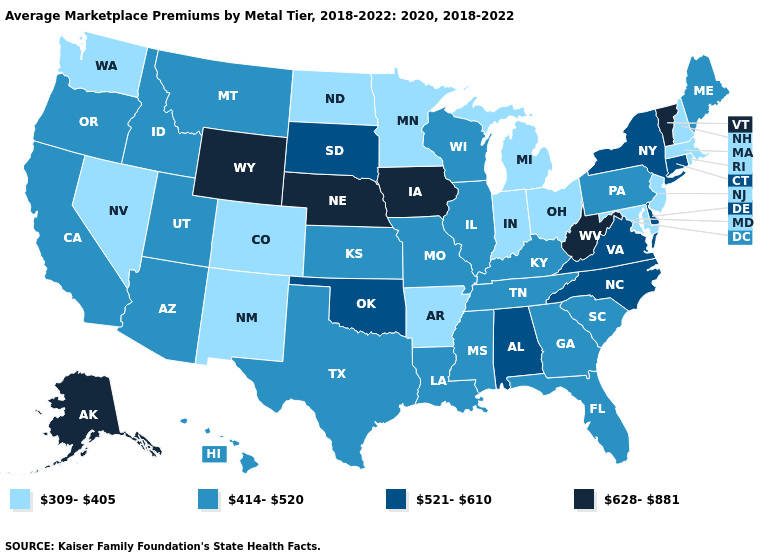Name the states that have a value in the range 309-405?
Answer briefly. Arkansas, Colorado, Indiana, Maryland, Massachusetts, Michigan, Minnesota, Nevada, New Hampshire, New Jersey, New Mexico, North Dakota, Ohio, Rhode Island, Washington. Among the states that border Kentucky , does Missouri have the lowest value?
Short answer required. No. Which states have the lowest value in the USA?
Answer briefly. Arkansas, Colorado, Indiana, Maryland, Massachusetts, Michigan, Minnesota, Nevada, New Hampshire, New Jersey, New Mexico, North Dakota, Ohio, Rhode Island, Washington. Does the map have missing data?
Concise answer only. No. Does the map have missing data?
Keep it brief. No. Name the states that have a value in the range 309-405?
Give a very brief answer. Arkansas, Colorado, Indiana, Maryland, Massachusetts, Michigan, Minnesota, Nevada, New Hampshire, New Jersey, New Mexico, North Dakota, Ohio, Rhode Island, Washington. How many symbols are there in the legend?
Be succinct. 4. What is the value of Kansas?
Concise answer only. 414-520. Does the map have missing data?
Be succinct. No. What is the value of Connecticut?
Concise answer only. 521-610. Which states hav the highest value in the West?
Be succinct. Alaska, Wyoming. What is the value of Michigan?
Short answer required. 309-405. Name the states that have a value in the range 628-881?
Short answer required. Alaska, Iowa, Nebraska, Vermont, West Virginia, Wyoming. What is the highest value in states that border Idaho?
Keep it brief. 628-881. Which states have the highest value in the USA?
Keep it brief. Alaska, Iowa, Nebraska, Vermont, West Virginia, Wyoming. 